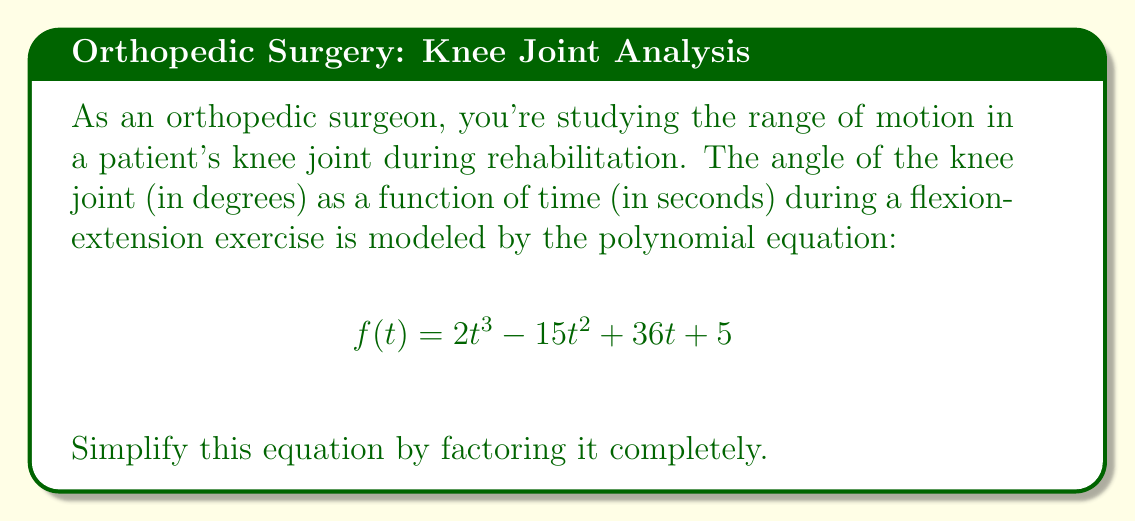Show me your answer to this math problem. To factor this polynomial completely, we'll follow these steps:

1) First, let's check if there's a common factor:
   $$2t^3 - 15t^2 + 36t + 5$$
   There's no common factor for all terms.

2) Next, let's try to factor by grouping:
   $$(2t^3 - 15t^2) + (36t + 5)$$
   $$(2t^2(t - \frac{15}{2})) + (36t + 5)$$
   This doesn't lead to a common factor, so grouping doesn't work.

3) Since this is a cubic equation, let's try to find a root by testing factors of the constant term (5):
   Possible factors: ±1, ±5
   
   Testing $f(-1)$:
   $$f(-1) = 2(-1)^3 - 15(-1)^2 + 36(-1) + 5 = -2 - 15 - 36 + 5 = -48$$
   
   Testing $f(1)$:
   $$f(1) = 2(1)^3 - 15(1)^2 + 36(1) + 5 = 2 - 15 + 36 + 5 = 28$$
   
   Since $f(-1)$ and $f(1)$ have different signs, there's a root between -1 and 1.

4) By further testing, we find that $f(\frac{1}{2}) = 0$

5) So, $(t - \frac{1}{2})$ is a factor. Let's divide the polynomial by $(t - \frac{1}{2})$:

   $$\frac{2t^3 - 15t^2 + 36t + 5}{t - \frac{1}{2}} = 2t^2 - 14t + 29$$

6) The resulting quadratic equation $2t^2 - 14t + 29$ doesn't factor further.

Therefore, the completely factored form is:

$$f(t) = (t - \frac{1}{2})(2t^2 - 14t + 29)$$
Answer: $$(t - \frac{1}{2})(2t^2 - 14t + 29)$$ 